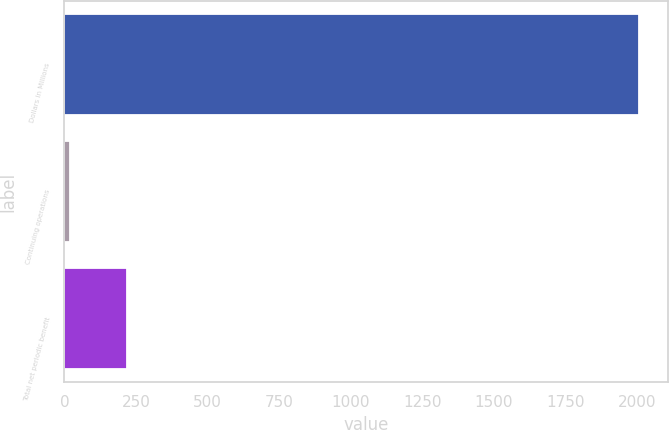Convert chart. <chart><loc_0><loc_0><loc_500><loc_500><bar_chart><fcel>Dollars in Millions<fcel>Continuing operations<fcel>Total net periodic benefit<nl><fcel>2008<fcel>19<fcel>217.9<nl></chart> 